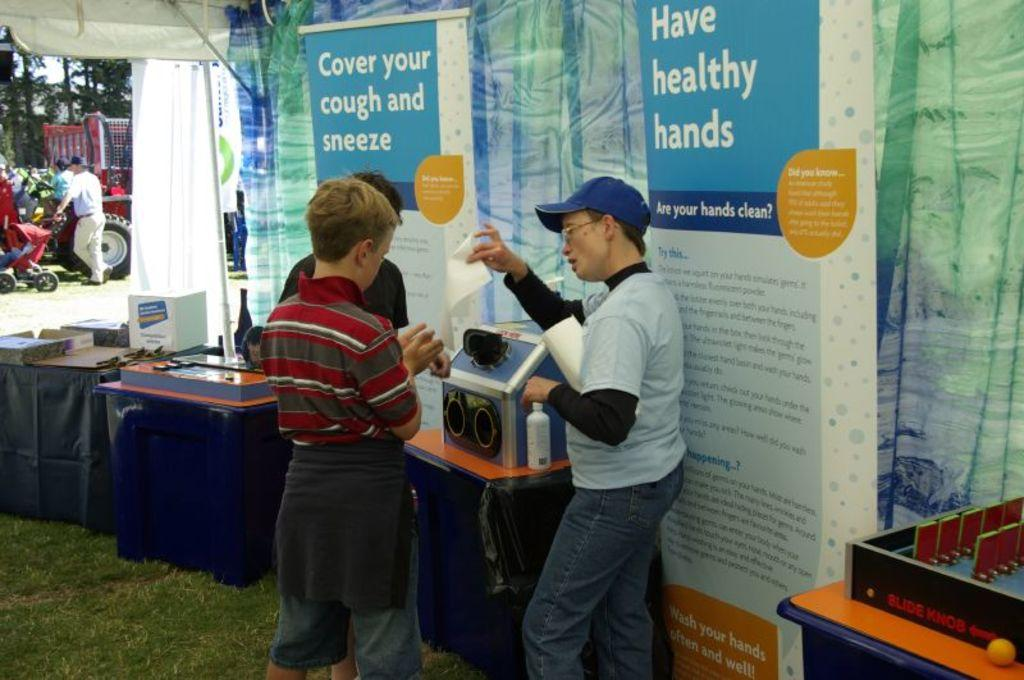<image>
Present a compact description of the photo's key features. Two people speaking near a sign which says "Cover and cough and sneeze". 